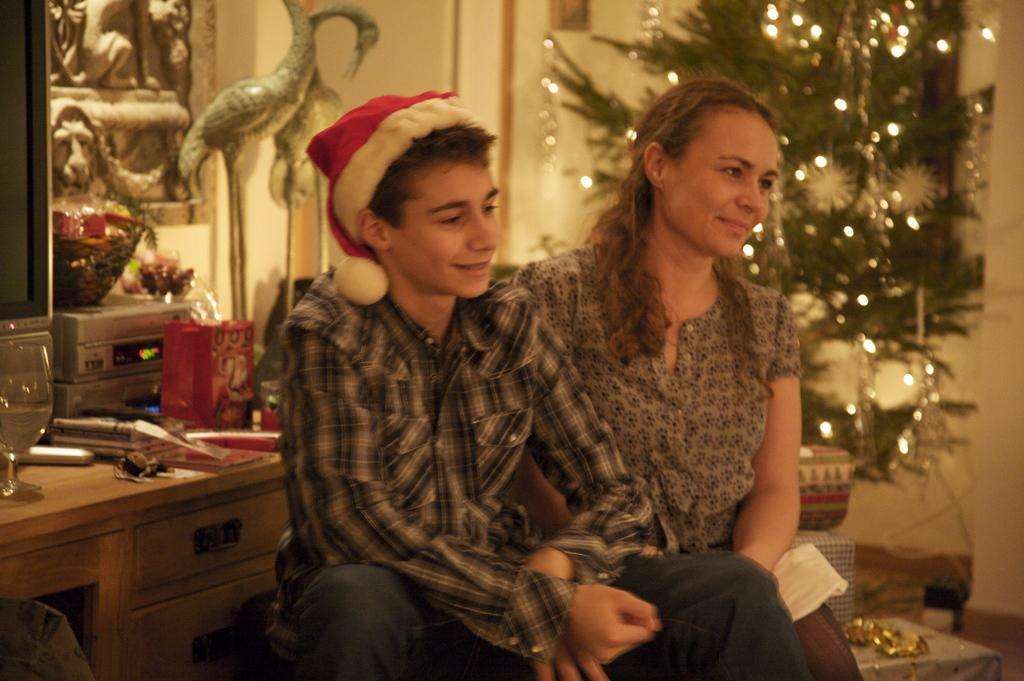How many people are present in the image? There is a man and a woman in the image. What is the man wearing on his head? The man is wearing a cap on his head. What type of furniture can be seen in the image? There is a table in the image. What type of electronic device is present in the image? There is a TV in the image. What type of structure is visible in the image? There is a wall in the image. What type of artwork is present in the image? There are sculptures in the image. What type of holiday decoration is present in the image? There is a Christmas tree in the image. What type of crook is trying to steal the Christmas tree in the image? There is no crook or theft depicted in the image; it simply shows a man, a woman, a table, a TV, a wall, sculptures, and a Christmas tree. How much money is the man adding to the woman's bank account in the image? There is no mention of money or banking in the image; it simply shows a man, a woman, a table, a TV, a wall, sculptures, and a Christmas tree. 